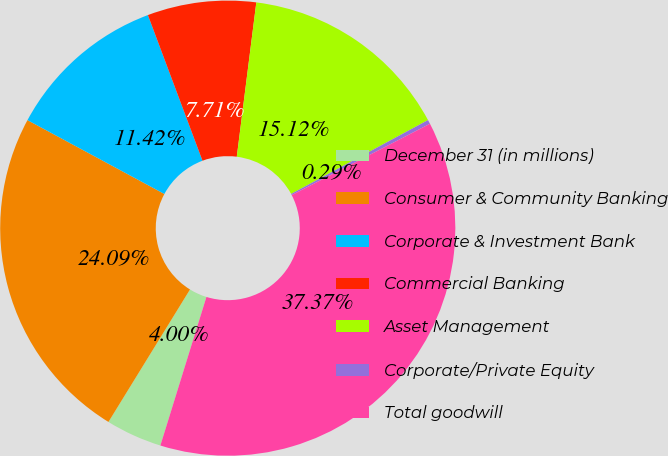Convert chart to OTSL. <chart><loc_0><loc_0><loc_500><loc_500><pie_chart><fcel>December 31 (in millions)<fcel>Consumer & Community Banking<fcel>Corporate & Investment Bank<fcel>Commercial Banking<fcel>Asset Management<fcel>Corporate/Private Equity<fcel>Total goodwill<nl><fcel>4.0%<fcel>24.09%<fcel>11.42%<fcel>7.71%<fcel>15.12%<fcel>0.29%<fcel>37.37%<nl></chart> 